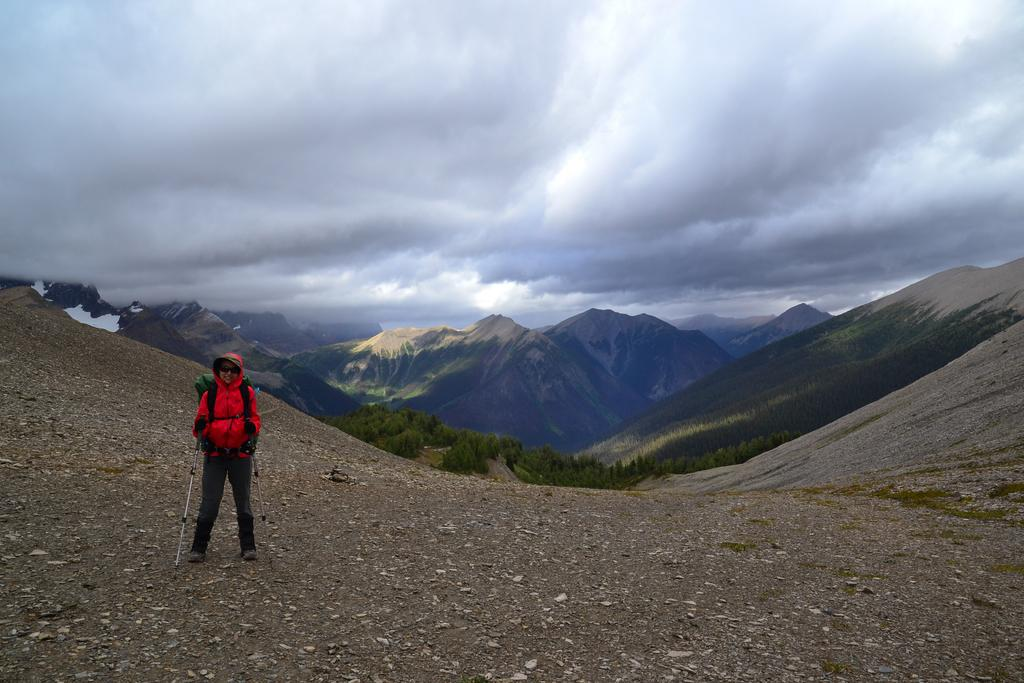What is the main subject of the image? There is a person in the image. What is the person doing in the image? The person is standing. What accessories is the person wearing in the image? The person is wearing a backpack and goggles. What is the person holding in the image? The person is holding sticks. What can be seen in the background of the image? There are mountains, trees, and a cloudy sky in the background of the image. Is there any blood visible on the person's clothing in the image? No, there is no blood visible on the person's clothing in the image. What type of picture is the person holding in their hand in the image? There is no picture visible in the person's hand in the image. 